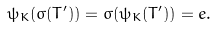Convert formula to latex. <formula><loc_0><loc_0><loc_500><loc_500>\psi _ { K } ( \sigma ( T ^ { \prime } ) ) = \sigma ( \psi _ { K } ( T ^ { \prime } ) ) = e .</formula> 